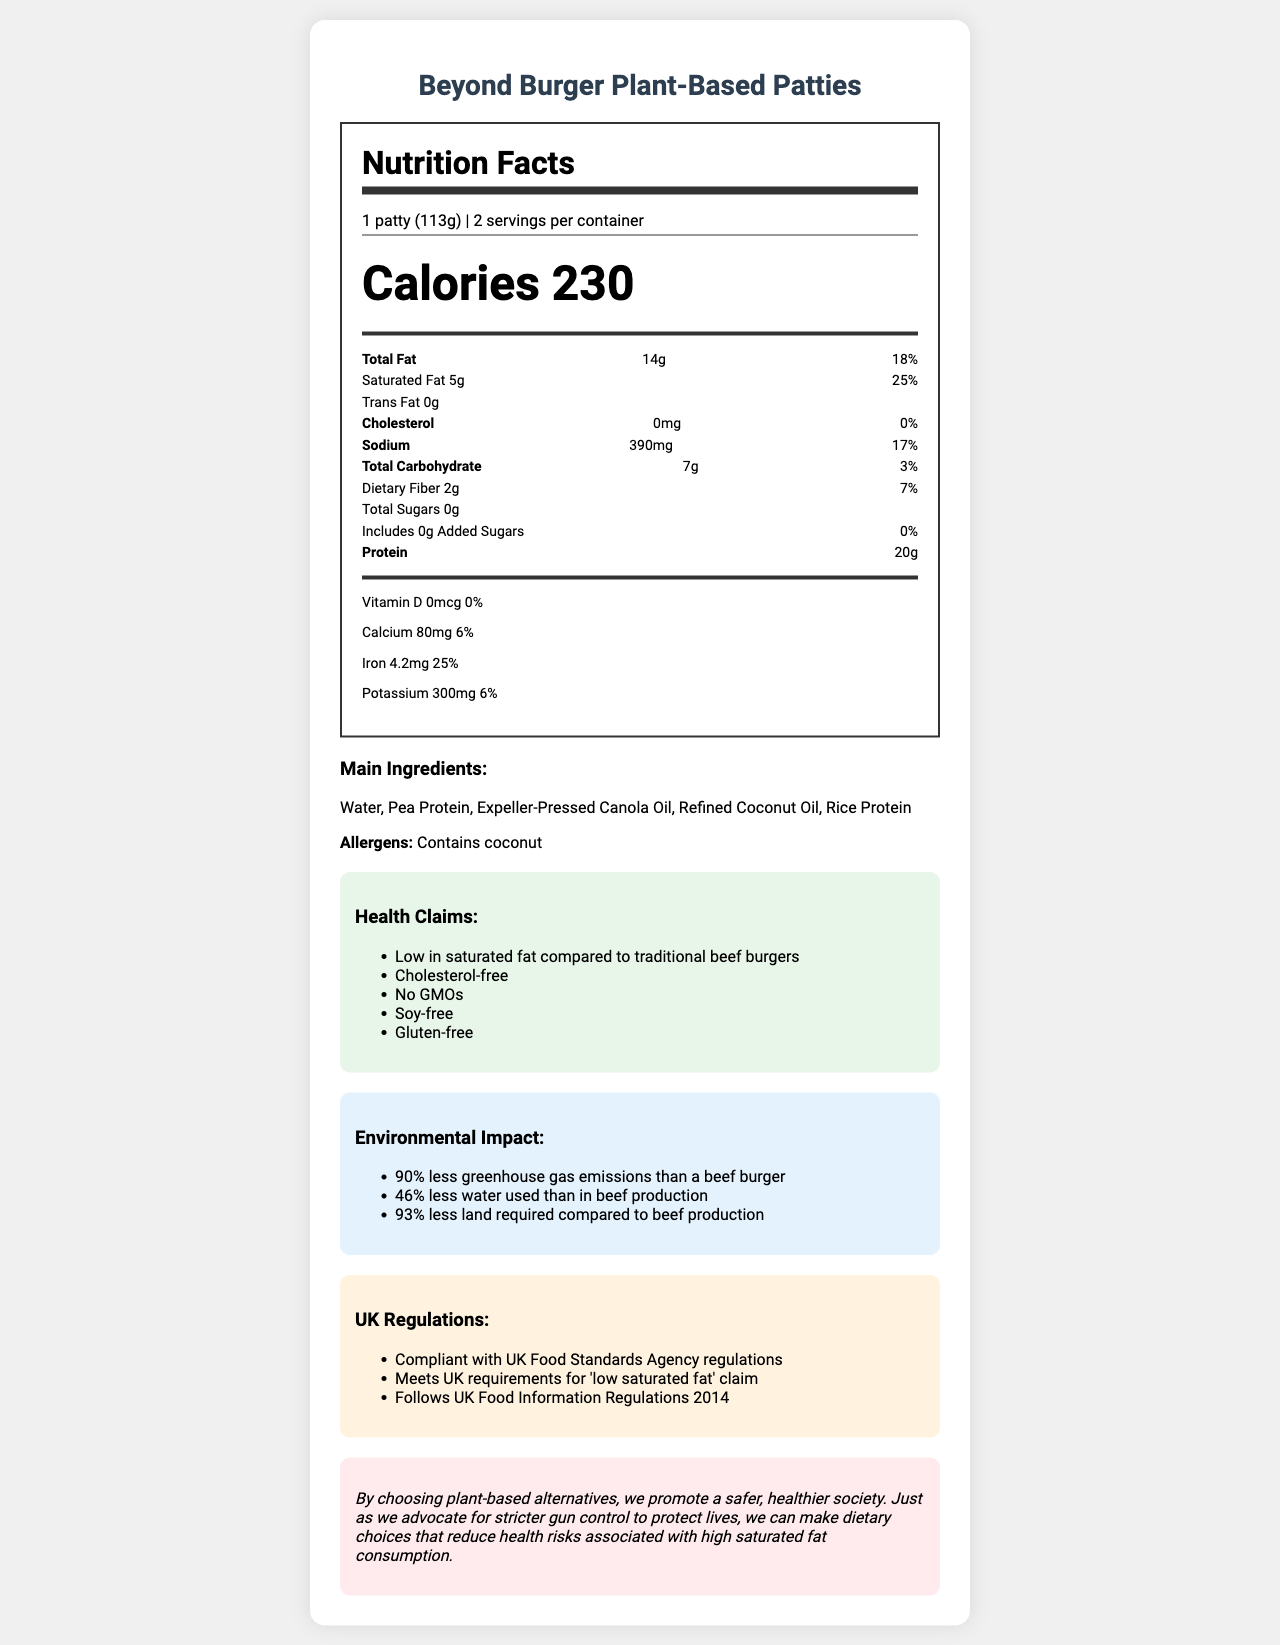what is the serving size? The serving size is clearly stated as "1 patty (113g)" in the document.
Answer: 1 patty (113g) how many calories are in one serving? The document specifies that there are 230 calories per serving.
Answer: 230 how much saturated fat does one patty contain? The saturated fat content per serving is listed as 5g.
Answer: 5g what are the main ingredients? The main ingredients are shown under the "Main Ingredients" section.
Answer: Water, Pea Protein, Expeller-Pressed Canola Oil, Refined Coconut Oil, Rice Protein are there any allergens listed in the ingredients? The document lists coconut as an allergen in the "Allergens" section.
Answer: Yes, coconut how does the Beyond Burger compare to traditional beef burgers in terms of saturated fat? A. Higher in saturated fat B. Same amount of saturated fat C. Lower in saturated fat D. Information not provided The health claims section states that the product is "Low in saturated fat compared to traditional beef burgers".
Answer: C which of the following is not a health claim made about Beyond Burger? A. Cholesterol-free B. Contains GMOs C. Soy-free D. Gluten-free The document states that the Beyond Burger has "No GMOs," so it does not contain GMOs.
Answer: B is the Beyond Burger compliant with UK Food Standards Agency regulations? The "UK Regulations" section states that the product is compliant with UK Food Standards Agency regulations.
Answer: Yes is the product suitable for someone who has celiac disease? The product is listed as "Gluten-free," making it suitable for someone with celiac disease.
Answer: Yes describe the overall environmental impact of the Beyond Burger. The "Environmental Impact" section provides detailed percentages on the reduced greenhouse gas emissions, water usage, and land requirements compared to beef production.
Answer: The Beyond Burger has significantly less environmental impact compared to beef burgers, with 90% less greenhouse gas emissions, 46% less water usage, and 93% less land required. can this product help in reducing cholesterol levels? The product contains "0mg" of cholesterol, and one of the health claims is that it is "Cholesterol-free," which can help in reducing cholesterol levels.
Answer: Yes how much iron is in one serving of Beyond Burger? The nutrition facts state that one serving contains 4.2mg of iron.
Answer: 4.2mg what is the purpose of the last section labeled "Advocacy Note"? The "Advocacy Note" emphasizes that choosing plant-based alternatives promotes a safer, healthier society, and makes an analogy to advocating for stricter gun control measures.
Answer: To promote societal benefits through safer and healthier choices, drawing a parallel between plant-based diets and stricter gun control. how many servings are contained in one package of Beyond Burger? The document mentions "2 servings per container".
Answer: 2 what is the percent Daily Value (%DV) of dietary fiber in one serving? The percent Daily Value for dietary fiber is given as 7%.
Answer: 7% is vitamin B12 listed in the nutritional information? The document does not provide any information on vitamin B12.
Answer: Not enough information describe the Beyond Burger Plant-Based Patties document. The document covers various aspects of the Beyond Burger Plant-Based Patties, including nutritional facts, ingredients, allergens, health claims, environmental impact, regulatory compliance, and an advocacy note. It provides a comprehensive overview of the product, emphasizing its health and environmental benefits.
Answer: The document provides detailed nutritional information, health claims, environmental impact, compliance with UK regulations, and an advocacy note promoting the benefits of choosing plant-based alternatives. It highlights key nutritional data, including low saturated fat, cholesterol-free claims, and the environmental benefits compared to traditional beef burgers. 